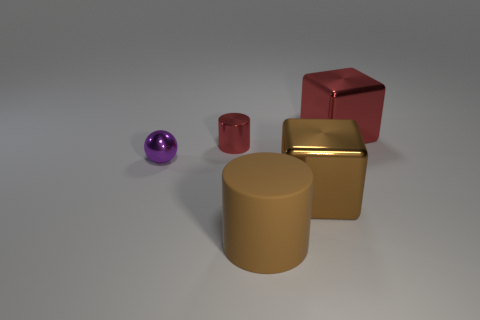Add 2 tiny blue cubes. How many objects exist? 7 Subtract all balls. How many objects are left? 4 Subtract all metallic balls. Subtract all big matte cylinders. How many objects are left? 3 Add 5 big brown cylinders. How many big brown cylinders are left? 6 Add 2 large brown metallic objects. How many large brown metallic objects exist? 3 Subtract 0 gray spheres. How many objects are left? 5 